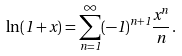Convert formula to latex. <formula><loc_0><loc_0><loc_500><loc_500>\ln ( 1 + x ) = \sum _ { n = 1 } ^ { \infty } ( - 1 ) ^ { n + 1 } \frac { x ^ { n } } { n } \, .</formula> 